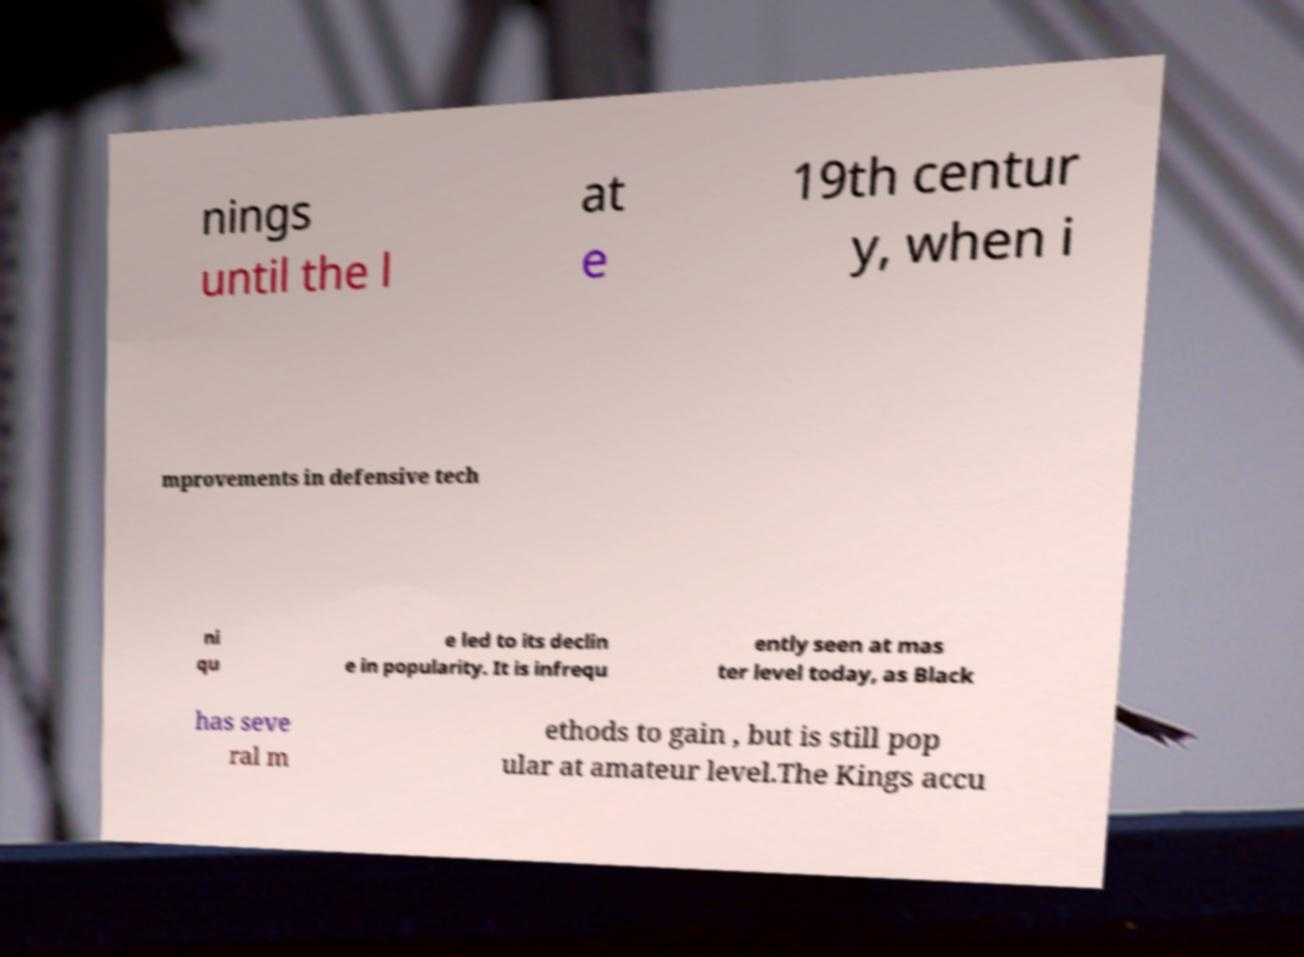I need the written content from this picture converted into text. Can you do that? nings until the l at e 19th centur y, when i mprovements in defensive tech ni qu e led to its declin e in popularity. It is infrequ ently seen at mas ter level today, as Black has seve ral m ethods to gain , but is still pop ular at amateur level.The Kings accu 